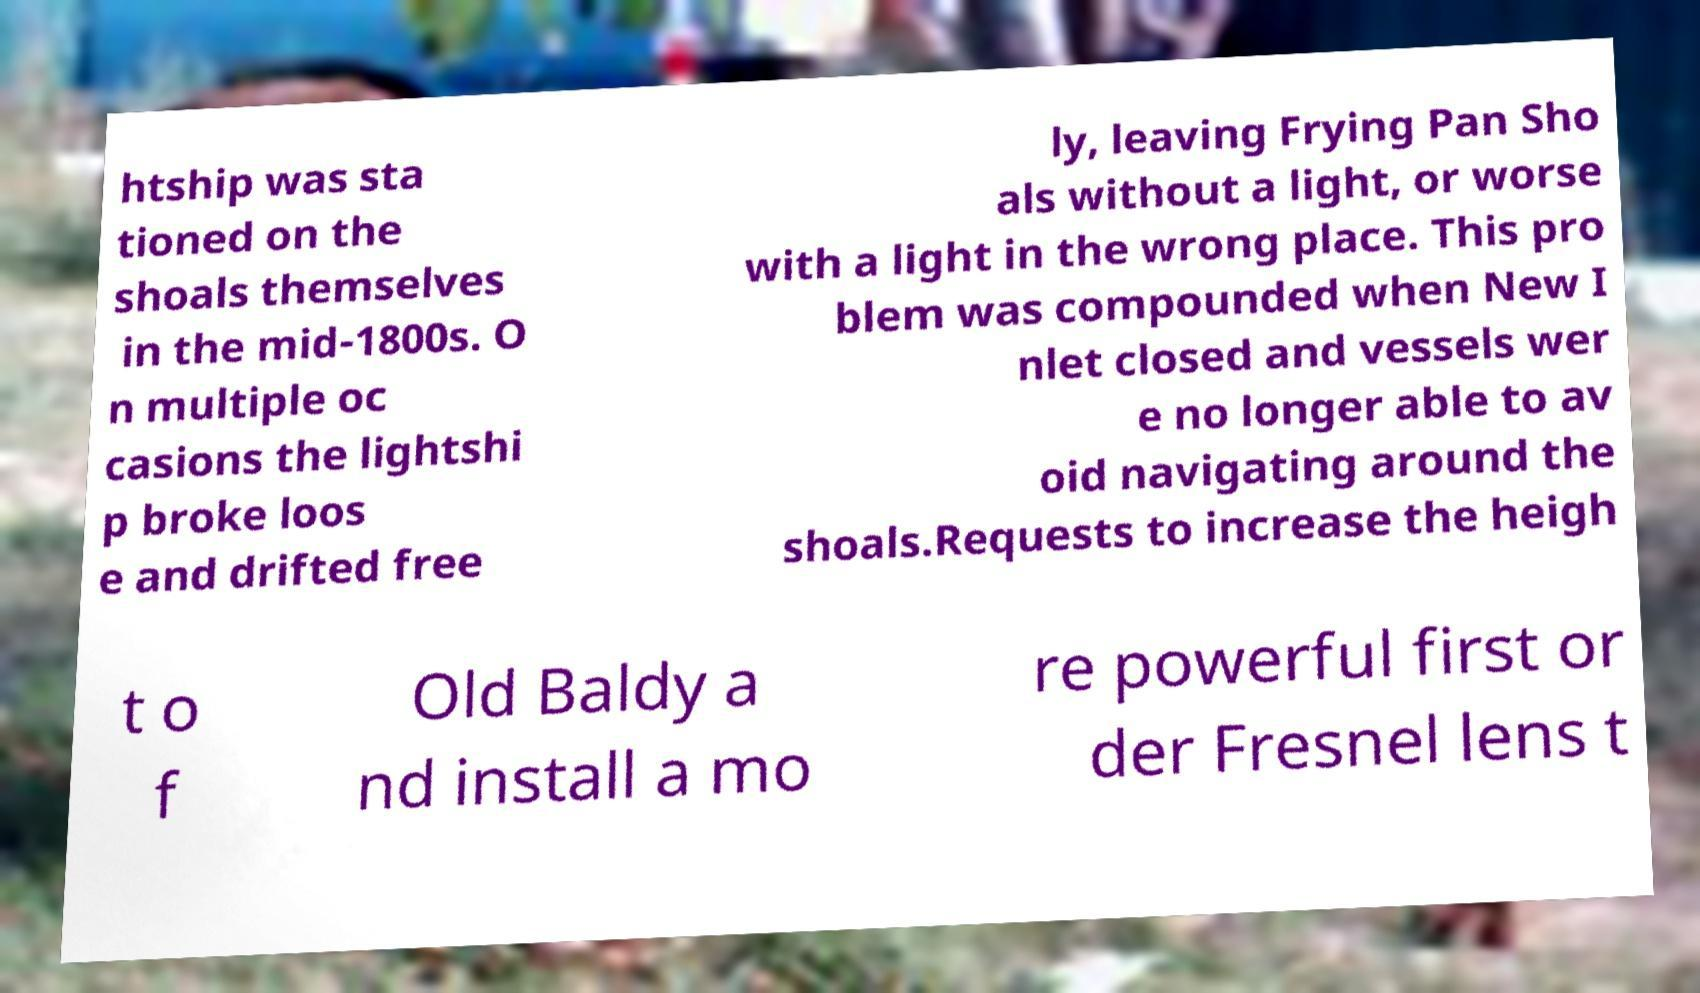Can you read and provide the text displayed in the image?This photo seems to have some interesting text. Can you extract and type it out for me? htship was sta tioned on the shoals themselves in the mid-1800s. O n multiple oc casions the lightshi p broke loos e and drifted free ly, leaving Frying Pan Sho als without a light, or worse with a light in the wrong place. This pro blem was compounded when New I nlet closed and vessels wer e no longer able to av oid navigating around the shoals.Requests to increase the heigh t o f Old Baldy a nd install a mo re powerful first or der Fresnel lens t 